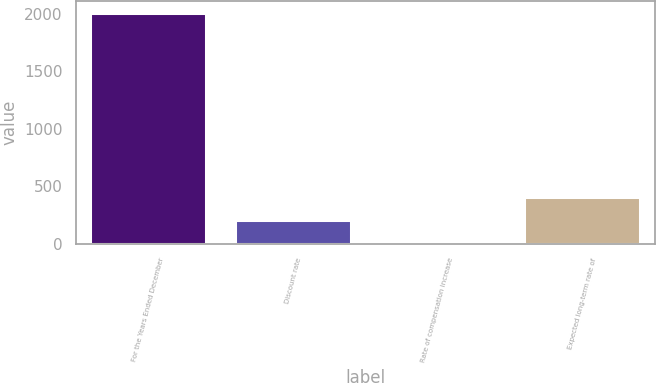Convert chart to OTSL. <chart><loc_0><loc_0><loc_500><loc_500><bar_chart><fcel>For the Years Ended December<fcel>Discount rate<fcel>Rate of compensation increase<fcel>Expected long-term rate of<nl><fcel>2011<fcel>204.53<fcel>3.81<fcel>405.25<nl></chart> 